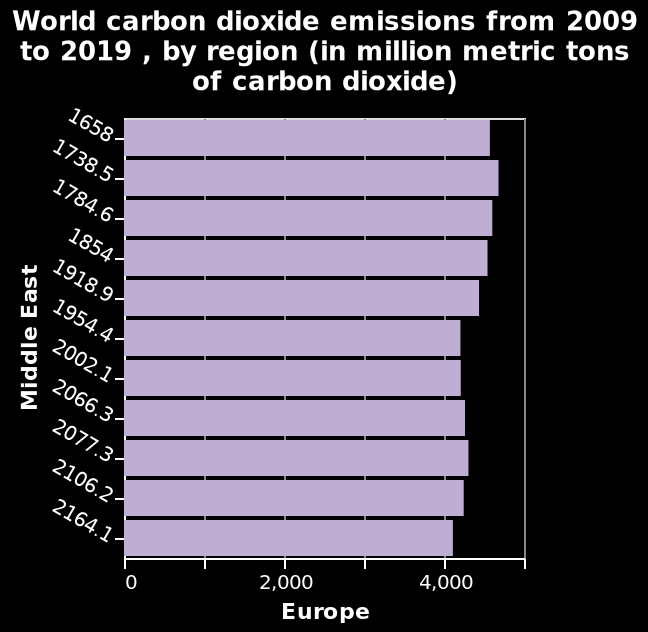<image>
What is the name of the bar diagram?  The bar diagram is named "World carbon dioxide emissions from 2009 to 2019, by region (in million metric tons of carbon dioxide)". Offer a thorough analysis of the image. the bar charts attempt to visualise world carbon dioxide emissions. What region is shown on the y-axis of the bar diagram?  The region shown on the y-axis of the bar diagram is the Middle East. please enumerates aspects of the construction of the chart This is a bar diagram named World carbon dioxide emissions from 2009 to 2019 , by region (in million metric tons of carbon dioxide). Middle East is shown on the y-axis. A linear scale with a minimum of 0 and a maximum of 5,000 can be seen along the x-axis, marked Europe. 